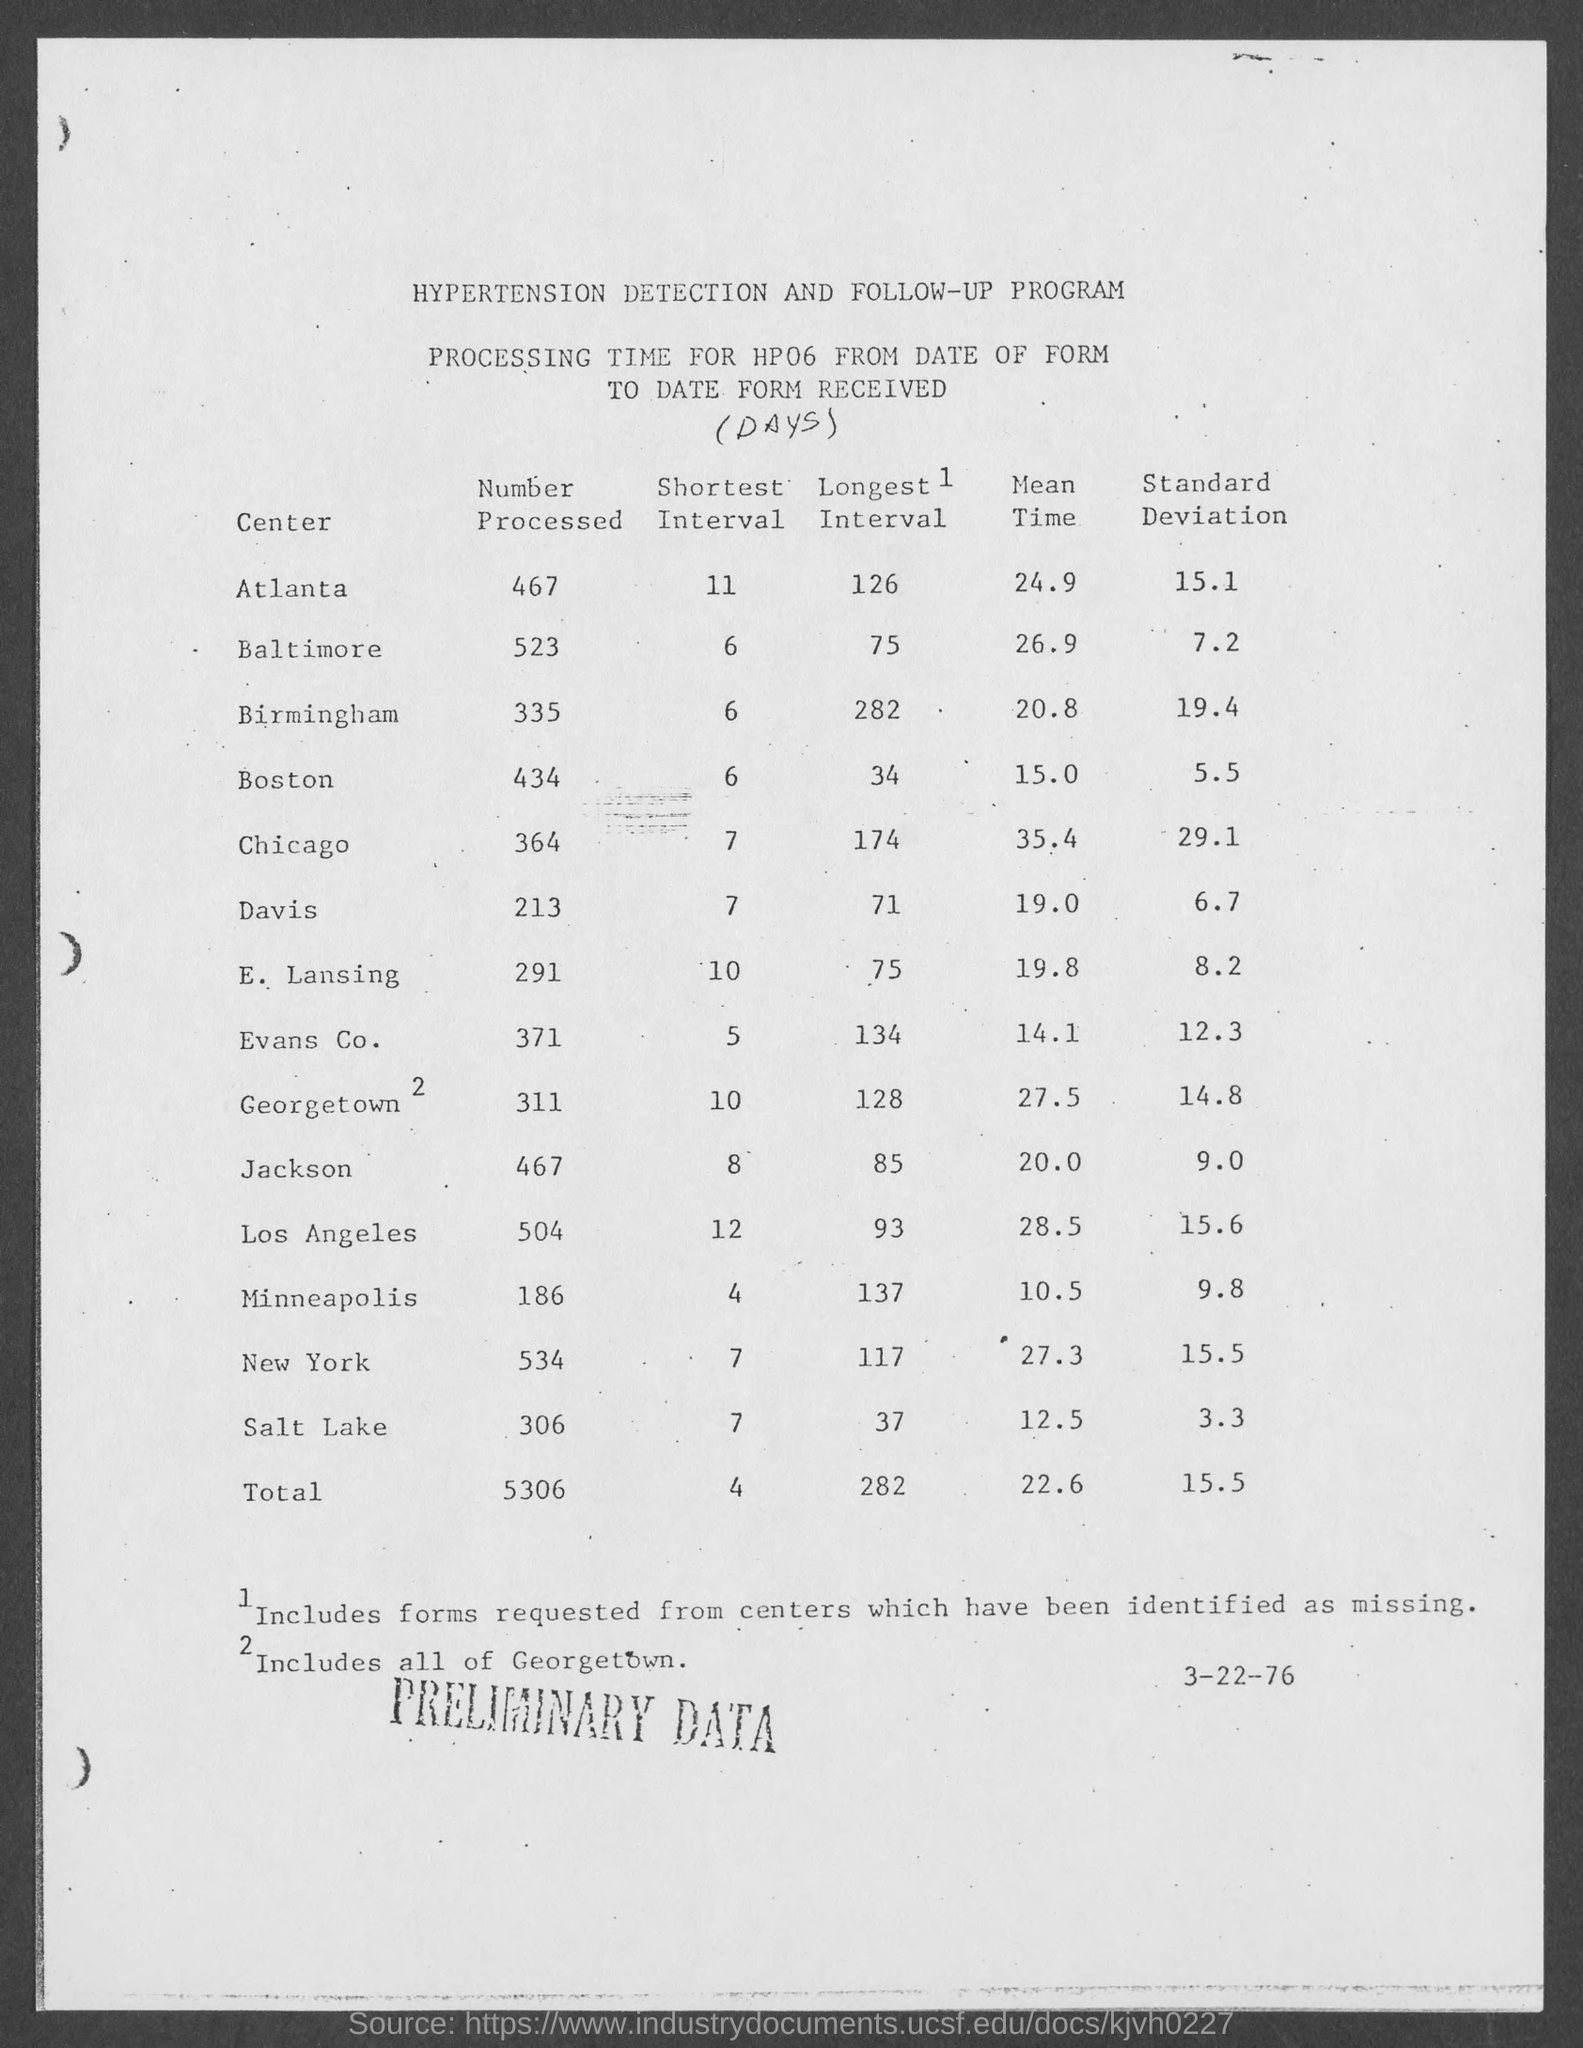List a handful of essential elements in this visual. The standard deviation of the Atlanta center is approximately 15.1. 